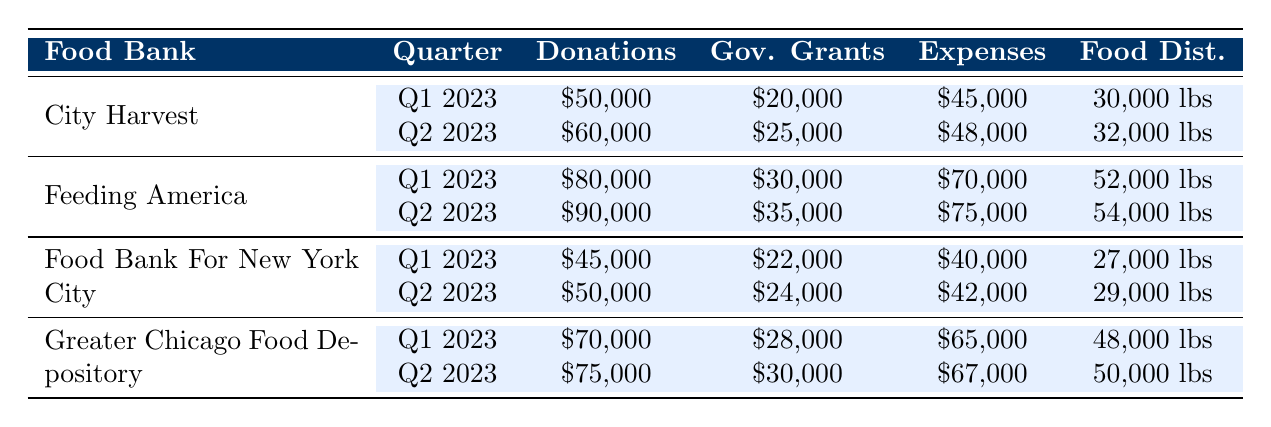What is the total amount of donations received by City Harvest in Q1 and Q2 of 2023? The donations received by City Harvest in Q1 are 50,000 and in Q2 are 60,000. To find the total, we sum these two values: 50,000 + 60,000 = 110,000.
Answer: 110,000 Which food bank distributed the most food in Q2 of 2023? Looking at Q2 of 2023, City Harvest distributed 32,000 lbs, Feeding America distributed 54,000 lbs, Food Bank For New York City distributed 29,000 lbs, and Greater Chicago Food Depository distributed 50,000 lbs. The highest amount is from Feeding America.
Answer: Feeding America Did Greater Chicago Food Depository receive more government grants in Q2 than City Harvest received in Q1? Greater Chicago Food Depository received 30,000 in Q2 and City Harvest received 20,000 in Q1. Since 30,000 is greater than 20,000, the statement is true.
Answer: Yes What was the increase in operating expenses from Q1 to Q2 for Feeding America? The operating expenses for Feeding America in Q1 are 70,000 and in Q2 they are 75,000. To find the increase, we subtract: 75,000 - 70,000 = 5,000.
Answer: 5,000 Is the total food distributed by Food Bank For New York City in Q1 less than 30,000 lbs? Food Bank For New York City distributed 27,000 lbs in Q1. Since 27,000 is less than 30,000, the statement is true.
Answer: Yes What is the average amount of donations received by all food banks in Q1 of 2023? The donations in Q1 are 50,000 (City Harvest) + 80,000 (Feeding America) + 45,000 (Food Bank For New York City) + 70,000 (Greater Chicago Food Depository) = 245,000. There are 4 banks, so we calculate the average: 245,000 / 4 = 61,250.
Answer: 61,250 Which quarter had the lowest total government grants among all food banks? To find this, we total the government grants by quarter: Q1: 20,000 + 30,000 + 22,000 + 28,000 = 100,000; Q2: 25,000 + 35,000 + 24,000 + 30,000 = 114,000. Since 100,000 (Q1) is less than 114,000 (Q2), Q1 had the lowest total.
Answer: Q1 Has the number of volunteer hours increased from Q1 to Q2 for City Harvest? In Q1, City Harvest had 2,500 volunteer hours and in Q2 it had 2,700 hours. Since 2,700 is greater than 2,500, there was an increase in volunteer hours.
Answer: Yes 